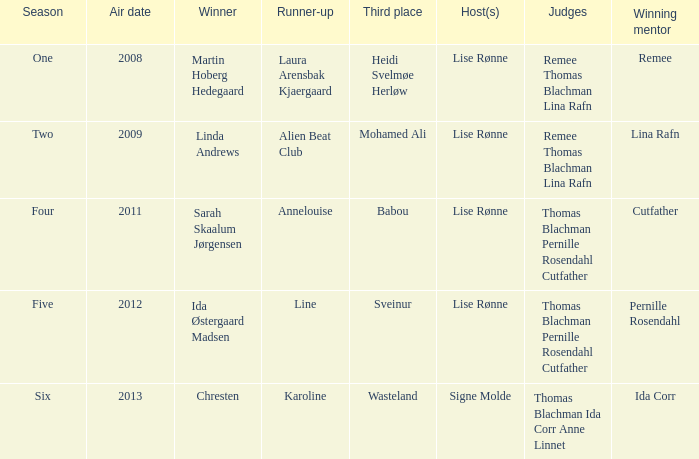Who obtained the second position when mohamed ali ranked third? Alien Beat Club. 